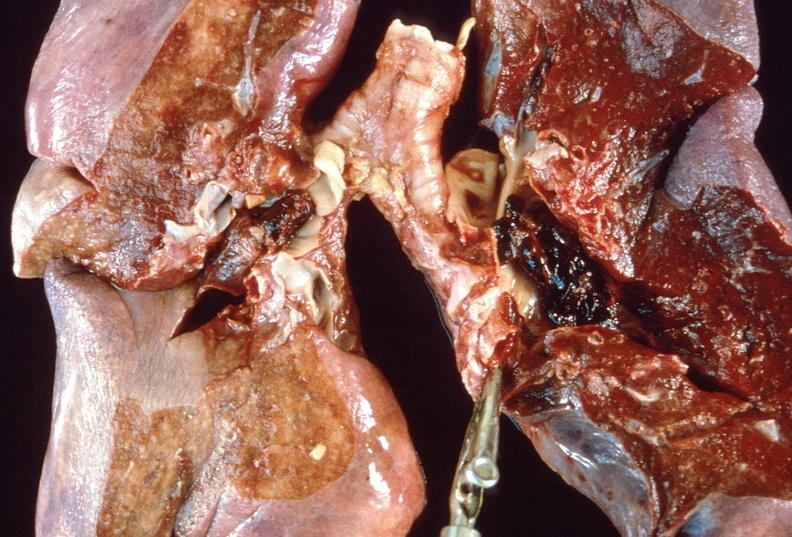does iron show pulmonary thromboemboli?
Answer the question using a single word or phrase. No 